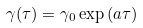Convert formula to latex. <formula><loc_0><loc_0><loc_500><loc_500>\gamma ( \tau ) = \gamma _ { 0 } \exp { ( a \tau ) }</formula> 